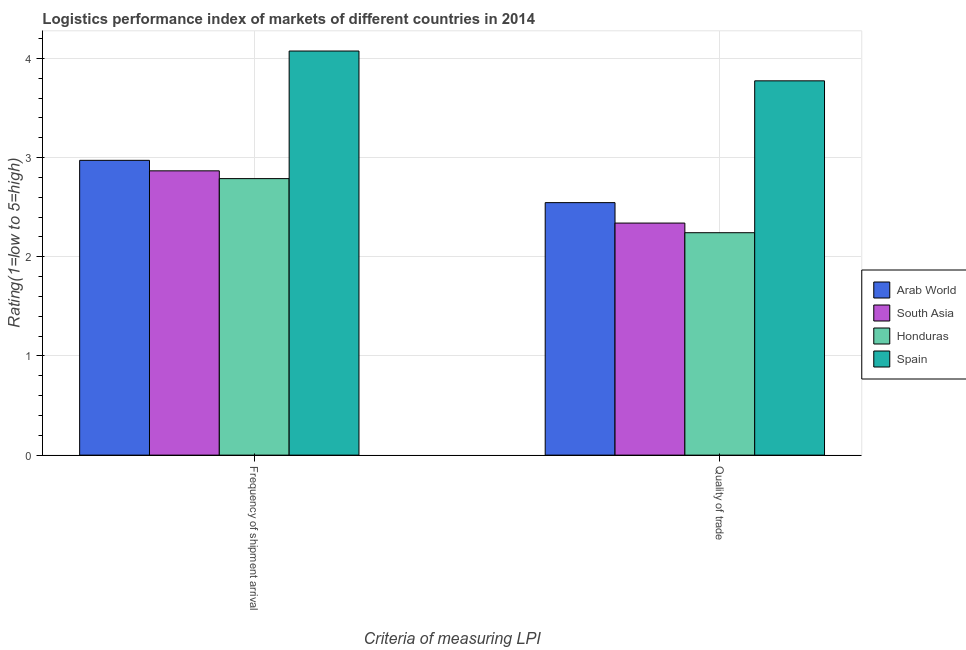How many different coloured bars are there?
Offer a terse response. 4. How many groups of bars are there?
Make the answer very short. 2. Are the number of bars on each tick of the X-axis equal?
Your response must be concise. Yes. How many bars are there on the 1st tick from the left?
Provide a short and direct response. 4. How many bars are there on the 2nd tick from the right?
Keep it short and to the point. 4. What is the label of the 2nd group of bars from the left?
Keep it short and to the point. Quality of trade. What is the lpi of frequency of shipment arrival in Spain?
Your response must be concise. 4.07. Across all countries, what is the maximum lpi of frequency of shipment arrival?
Your answer should be very brief. 4.07. Across all countries, what is the minimum lpi quality of trade?
Make the answer very short. 2.24. In which country was the lpi quality of trade maximum?
Provide a short and direct response. Spain. In which country was the lpi of frequency of shipment arrival minimum?
Your answer should be compact. Honduras. What is the total lpi quality of trade in the graph?
Give a very brief answer. 10.9. What is the difference between the lpi quality of trade in South Asia and that in Honduras?
Your response must be concise. 0.1. What is the difference between the lpi of frequency of shipment arrival in South Asia and the lpi quality of trade in Arab World?
Offer a very short reply. 0.32. What is the average lpi quality of trade per country?
Your answer should be compact. 2.73. What is the difference between the lpi quality of trade and lpi of frequency of shipment arrival in Spain?
Give a very brief answer. -0.3. In how many countries, is the lpi of frequency of shipment arrival greater than 1 ?
Your answer should be very brief. 4. What is the ratio of the lpi of frequency of shipment arrival in Honduras to that in South Asia?
Your answer should be very brief. 0.97. Is the lpi of frequency of shipment arrival in Spain less than that in Honduras?
Ensure brevity in your answer.  No. In how many countries, is the lpi quality of trade greater than the average lpi quality of trade taken over all countries?
Your answer should be compact. 1. Are all the bars in the graph horizontal?
Make the answer very short. No. What is the difference between two consecutive major ticks on the Y-axis?
Your answer should be very brief. 1. Are the values on the major ticks of Y-axis written in scientific E-notation?
Offer a very short reply. No. Does the graph contain any zero values?
Your answer should be compact. No. Does the graph contain grids?
Make the answer very short. Yes. Where does the legend appear in the graph?
Offer a very short reply. Center right. How are the legend labels stacked?
Give a very brief answer. Vertical. What is the title of the graph?
Your response must be concise. Logistics performance index of markets of different countries in 2014. Does "South Sudan" appear as one of the legend labels in the graph?
Provide a short and direct response. No. What is the label or title of the X-axis?
Ensure brevity in your answer.  Criteria of measuring LPI. What is the label or title of the Y-axis?
Make the answer very short. Rating(1=low to 5=high). What is the Rating(1=low to 5=high) in Arab World in Frequency of shipment arrival?
Your answer should be very brief. 2.97. What is the Rating(1=low to 5=high) of South Asia in Frequency of shipment arrival?
Offer a very short reply. 2.87. What is the Rating(1=low to 5=high) of Honduras in Frequency of shipment arrival?
Your answer should be compact. 2.79. What is the Rating(1=low to 5=high) in Spain in Frequency of shipment arrival?
Keep it short and to the point. 4.07. What is the Rating(1=low to 5=high) in Arab World in Quality of trade?
Provide a succinct answer. 2.55. What is the Rating(1=low to 5=high) in South Asia in Quality of trade?
Offer a very short reply. 2.34. What is the Rating(1=low to 5=high) of Honduras in Quality of trade?
Keep it short and to the point. 2.24. What is the Rating(1=low to 5=high) in Spain in Quality of trade?
Ensure brevity in your answer.  3.77. Across all Criteria of measuring LPI, what is the maximum Rating(1=low to 5=high) in Arab World?
Ensure brevity in your answer.  2.97. Across all Criteria of measuring LPI, what is the maximum Rating(1=low to 5=high) in South Asia?
Make the answer very short. 2.87. Across all Criteria of measuring LPI, what is the maximum Rating(1=low to 5=high) of Honduras?
Your answer should be very brief. 2.79. Across all Criteria of measuring LPI, what is the maximum Rating(1=low to 5=high) in Spain?
Your answer should be compact. 4.07. Across all Criteria of measuring LPI, what is the minimum Rating(1=low to 5=high) of Arab World?
Give a very brief answer. 2.55. Across all Criteria of measuring LPI, what is the minimum Rating(1=low to 5=high) of South Asia?
Your answer should be very brief. 2.34. Across all Criteria of measuring LPI, what is the minimum Rating(1=low to 5=high) in Honduras?
Make the answer very short. 2.24. Across all Criteria of measuring LPI, what is the minimum Rating(1=low to 5=high) in Spain?
Ensure brevity in your answer.  3.77. What is the total Rating(1=low to 5=high) of Arab World in the graph?
Your response must be concise. 5.52. What is the total Rating(1=low to 5=high) of South Asia in the graph?
Provide a short and direct response. 5.21. What is the total Rating(1=low to 5=high) in Honduras in the graph?
Offer a terse response. 5.03. What is the total Rating(1=low to 5=high) of Spain in the graph?
Make the answer very short. 7.85. What is the difference between the Rating(1=low to 5=high) of Arab World in Frequency of shipment arrival and that in Quality of trade?
Give a very brief answer. 0.43. What is the difference between the Rating(1=low to 5=high) in South Asia in Frequency of shipment arrival and that in Quality of trade?
Your answer should be very brief. 0.53. What is the difference between the Rating(1=low to 5=high) in Honduras in Frequency of shipment arrival and that in Quality of trade?
Give a very brief answer. 0.55. What is the difference between the Rating(1=low to 5=high) of Spain in Frequency of shipment arrival and that in Quality of trade?
Make the answer very short. 0.3. What is the difference between the Rating(1=low to 5=high) of Arab World in Frequency of shipment arrival and the Rating(1=low to 5=high) of South Asia in Quality of trade?
Offer a terse response. 0.63. What is the difference between the Rating(1=low to 5=high) in Arab World in Frequency of shipment arrival and the Rating(1=low to 5=high) in Honduras in Quality of trade?
Your answer should be compact. 0.73. What is the difference between the Rating(1=low to 5=high) of Arab World in Frequency of shipment arrival and the Rating(1=low to 5=high) of Spain in Quality of trade?
Offer a terse response. -0.8. What is the difference between the Rating(1=low to 5=high) of South Asia in Frequency of shipment arrival and the Rating(1=low to 5=high) of Honduras in Quality of trade?
Offer a very short reply. 0.62. What is the difference between the Rating(1=low to 5=high) of South Asia in Frequency of shipment arrival and the Rating(1=low to 5=high) of Spain in Quality of trade?
Ensure brevity in your answer.  -0.91. What is the difference between the Rating(1=low to 5=high) of Honduras in Frequency of shipment arrival and the Rating(1=low to 5=high) of Spain in Quality of trade?
Your response must be concise. -0.99. What is the average Rating(1=low to 5=high) in Arab World per Criteria of measuring LPI?
Offer a very short reply. 2.76. What is the average Rating(1=low to 5=high) of South Asia per Criteria of measuring LPI?
Ensure brevity in your answer.  2.6. What is the average Rating(1=low to 5=high) of Honduras per Criteria of measuring LPI?
Offer a very short reply. 2.52. What is the average Rating(1=low to 5=high) in Spain per Criteria of measuring LPI?
Provide a short and direct response. 3.92. What is the difference between the Rating(1=low to 5=high) of Arab World and Rating(1=low to 5=high) of South Asia in Frequency of shipment arrival?
Make the answer very short. 0.11. What is the difference between the Rating(1=low to 5=high) of Arab World and Rating(1=low to 5=high) of Honduras in Frequency of shipment arrival?
Make the answer very short. 0.18. What is the difference between the Rating(1=low to 5=high) of Arab World and Rating(1=low to 5=high) of Spain in Frequency of shipment arrival?
Ensure brevity in your answer.  -1.1. What is the difference between the Rating(1=low to 5=high) in South Asia and Rating(1=low to 5=high) in Honduras in Frequency of shipment arrival?
Provide a succinct answer. 0.08. What is the difference between the Rating(1=low to 5=high) in South Asia and Rating(1=low to 5=high) in Spain in Frequency of shipment arrival?
Offer a very short reply. -1.21. What is the difference between the Rating(1=low to 5=high) of Honduras and Rating(1=low to 5=high) of Spain in Frequency of shipment arrival?
Give a very brief answer. -1.29. What is the difference between the Rating(1=low to 5=high) of Arab World and Rating(1=low to 5=high) of South Asia in Quality of trade?
Offer a very short reply. 0.21. What is the difference between the Rating(1=low to 5=high) of Arab World and Rating(1=low to 5=high) of Honduras in Quality of trade?
Your answer should be compact. 0.3. What is the difference between the Rating(1=low to 5=high) in Arab World and Rating(1=low to 5=high) in Spain in Quality of trade?
Your answer should be compact. -1.23. What is the difference between the Rating(1=low to 5=high) of South Asia and Rating(1=low to 5=high) of Honduras in Quality of trade?
Your answer should be very brief. 0.1. What is the difference between the Rating(1=low to 5=high) of South Asia and Rating(1=low to 5=high) of Spain in Quality of trade?
Your response must be concise. -1.43. What is the difference between the Rating(1=low to 5=high) in Honduras and Rating(1=low to 5=high) in Spain in Quality of trade?
Your response must be concise. -1.53. What is the ratio of the Rating(1=low to 5=high) of Arab World in Frequency of shipment arrival to that in Quality of trade?
Ensure brevity in your answer.  1.17. What is the ratio of the Rating(1=low to 5=high) in South Asia in Frequency of shipment arrival to that in Quality of trade?
Make the answer very short. 1.23. What is the ratio of the Rating(1=low to 5=high) of Honduras in Frequency of shipment arrival to that in Quality of trade?
Offer a terse response. 1.24. What is the ratio of the Rating(1=low to 5=high) of Spain in Frequency of shipment arrival to that in Quality of trade?
Offer a terse response. 1.08. What is the difference between the highest and the second highest Rating(1=low to 5=high) in Arab World?
Your response must be concise. 0.43. What is the difference between the highest and the second highest Rating(1=low to 5=high) in South Asia?
Offer a terse response. 0.53. What is the difference between the highest and the second highest Rating(1=low to 5=high) in Honduras?
Your answer should be compact. 0.55. What is the difference between the highest and the second highest Rating(1=low to 5=high) of Spain?
Your answer should be very brief. 0.3. What is the difference between the highest and the lowest Rating(1=low to 5=high) of Arab World?
Make the answer very short. 0.43. What is the difference between the highest and the lowest Rating(1=low to 5=high) of South Asia?
Provide a succinct answer. 0.53. What is the difference between the highest and the lowest Rating(1=low to 5=high) of Honduras?
Offer a very short reply. 0.55. What is the difference between the highest and the lowest Rating(1=low to 5=high) in Spain?
Your answer should be compact. 0.3. 